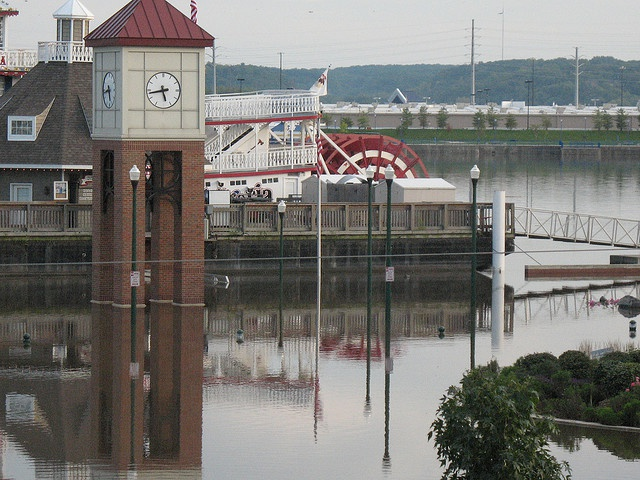Describe the objects in this image and their specific colors. I can see boat in lightgray, gray, black, and darkgray tones, clock in lightgray, darkgray, gray, and black tones, and clock in lightgray, darkgray, gray, and black tones in this image. 